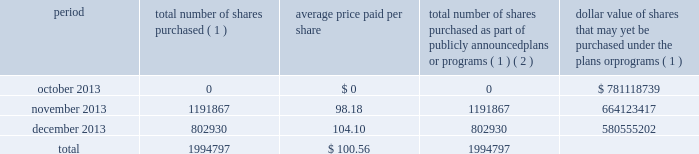Issuer purchases of equity securities the table provides information about purchases by us during the three months ended december 31 , 2013 of equity securities that are registered by us pursuant to section 12 of the exchange act : period total number of shares purchased ( 1 ) average price paid per share total number of shares purchased as part of publicly announced plans or programs ( 1 ) ( 2 ) dollar value of shares that may yet be purchased under the plans or programs ( 1 ) .
( 1 ) as announced on may 1 , 2013 , in april 2013 , the board of directors replaced its previously approved share repurchase authorization of up to $ 1 billion with a current authorization for repurchases of up to $ 1 billion of our common shares exclusive of shares repurchased in connection with employee stock plans , expiring on june 30 , 2015 .
Under the current share repurchase authorization , shares may be purchased from time to time at prevailing prices in the open market , by block purchases , or in privately-negotiated transactions , subject to certain regulatory restrictions on volume , pricing , and timing .
As of february 1 , 2014 , the remaining authorized amount under the current authorization totaled approximately $ 580 million .
( 2 ) excludes 0.1 million shares repurchased in connection with employee stock plans. .
What is the percentage of shares purchased in november concerning the whole 2013 year? 
Rationale: it is the number of shares purchased in november of 2013 divided by the total shares purchased in 2013 , then turned into a percentage .
Computations: (1191867 / 1994797)
Answer: 0.59749. Issuer purchases of equity securities the table provides information about purchases by us during the three months ended december 31 , 2013 of equity securities that are registered by us pursuant to section 12 of the exchange act : period total number of shares purchased ( 1 ) average price paid per share total number of shares purchased as part of publicly announced plans or programs ( 1 ) ( 2 ) dollar value of shares that may yet be purchased under the plans or programs ( 1 ) .
( 1 ) as announced on may 1 , 2013 , in april 2013 , the board of directors replaced its previously approved share repurchase authorization of up to $ 1 billion with a current authorization for repurchases of up to $ 1 billion of our common shares exclusive of shares repurchased in connection with employee stock plans , expiring on june 30 , 2015 .
Under the current share repurchase authorization , shares may be purchased from time to time at prevailing prices in the open market , by block purchases , or in privately-negotiated transactions , subject to certain regulatory restrictions on volume , pricing , and timing .
As of february 1 , 2014 , the remaining authorized amount under the current authorization totaled approximately $ 580 million .
( 2 ) excludes 0.1 million shares repurchased in connection with employee stock plans. .
What is the percentual increase observed in the average price paid per share during november and december of 2013? 
Rationale: it is the average price paid per share during december divided by november's one , then transformed into a percentage .
Computations: ((104.10 / 98.18) - 1)
Answer: 0.0603. Issuer purchases of equity securities the table provides information about purchases by us during the three months ended december 31 , 2013 of equity securities that are registered by us pursuant to section 12 of the exchange act : period total number of shares purchased ( 1 ) average price paid per share total number of shares purchased as part of publicly announced plans or programs ( 1 ) ( 2 ) dollar value of shares that may yet be purchased under the plans or programs ( 1 ) .
( 1 ) as announced on may 1 , 2013 , in april 2013 , the board of directors replaced its previously approved share repurchase authorization of up to $ 1 billion with a current authorization for repurchases of up to $ 1 billion of our common shares exclusive of shares repurchased in connection with employee stock plans , expiring on june 30 , 2015 .
Under the current share repurchase authorization , shares may be purchased from time to time at prevailing prices in the open market , by block purchases , or in privately-negotiated transactions , subject to certain regulatory restrictions on volume , pricing , and timing .
As of february 1 , 2014 , the remaining authorized amount under the current authorization totaled approximately $ 580 million .
( 2 ) excludes 0.1 million shares repurchased in connection with employee stock plans. .
What was the percent of the total number of shares purchased ( 1 ) in november 2013 to the total? 
Computations: (1191867 / 1994797)
Answer: 0.59749. Issuer purchases of equity securities the table provides information about purchases by us during the three months ended december 31 , 2013 of equity securities that are registered by us pursuant to section 12 of the exchange act : period total number of shares purchased ( 1 ) average price paid per share total number of shares purchased as part of publicly announced plans or programs ( 1 ) ( 2 ) dollar value of shares that may yet be purchased under the plans or programs ( 1 ) .
( 1 ) as announced on may 1 , 2013 , in april 2013 , the board of directors replaced its previously approved share repurchase authorization of up to $ 1 billion with a current authorization for repurchases of up to $ 1 billion of our common shares exclusive of shares repurchased in connection with employee stock plans , expiring on june 30 , 2015 .
Under the current share repurchase authorization , shares may be purchased from time to time at prevailing prices in the open market , by block purchases , or in privately-negotiated transactions , subject to certain regulatory restrictions on volume , pricing , and timing .
As of february 1 , 2014 , the remaining authorized amount under the current authorization totaled approximately $ 580 million .
( 2 ) excludes 0.1 million shares repurchased in connection with employee stock plans. .
What was the percent of the total number of shares purchased as part of publicly announced plans or programs ( 1 ) ( 2 ) in november 2013 to the total? 
Computations: (1191867 / 1994797)
Answer: 0.59749. 